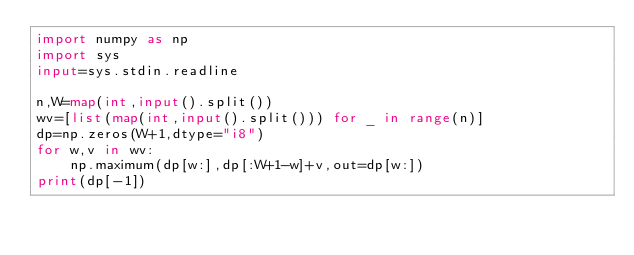Convert code to text. <code><loc_0><loc_0><loc_500><loc_500><_Python_>import numpy as np
import sys
input=sys.stdin.readline

n,W=map(int,input().split())
wv=[list(map(int,input().split())) for _ in range(n)]
dp=np.zeros(W+1,dtype="i8")
for w,v in wv:
    np.maximum(dp[w:],dp[:W+1-w]+v,out=dp[w:])
print(dp[-1])
</code> 